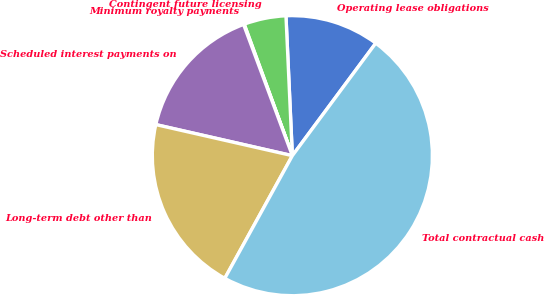<chart> <loc_0><loc_0><loc_500><loc_500><pie_chart><fcel>Operating lease obligations<fcel>Contingent future licensing<fcel>Minimum royalty payments<fcel>Scheduled interest payments on<fcel>Long-term debt other than<fcel>Total contractual cash<nl><fcel>10.88%<fcel>4.86%<fcel>0.08%<fcel>15.77%<fcel>20.55%<fcel>47.86%<nl></chart> 